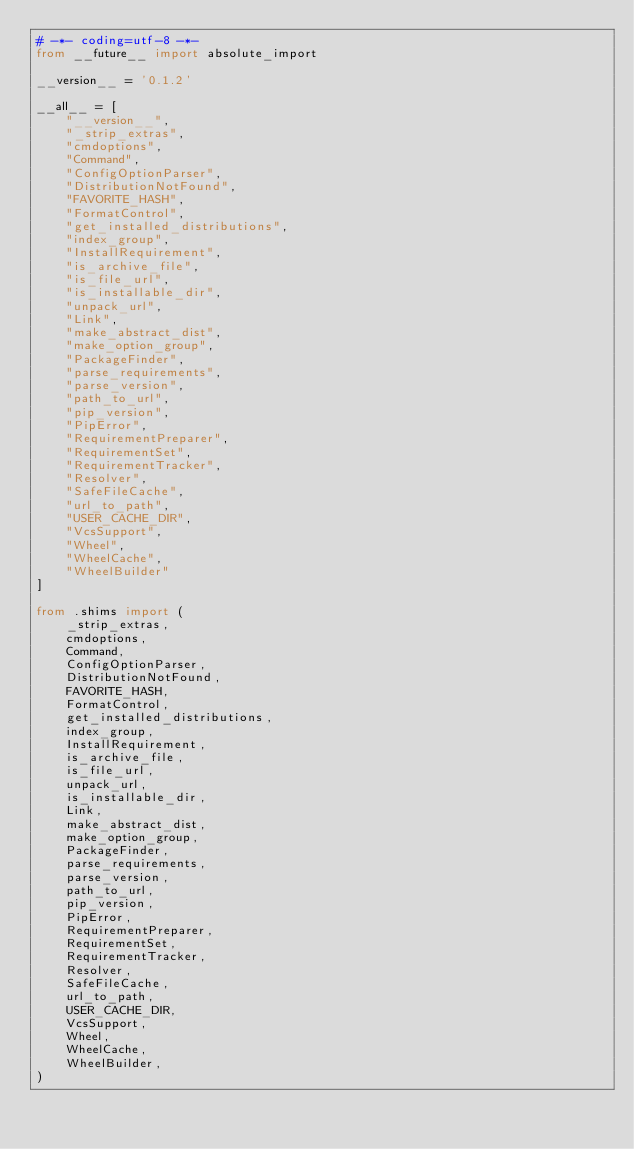Convert code to text. <code><loc_0><loc_0><loc_500><loc_500><_Python_># -*- coding=utf-8 -*-
from __future__ import absolute_import

__version__ = '0.1.2'

__all__ = [
    "__version__",
    "_strip_extras",
    "cmdoptions",
    "Command",
    "ConfigOptionParser",
    "DistributionNotFound",
    "FAVORITE_HASH",
    "FormatControl",
    "get_installed_distributions",
    "index_group",
    "InstallRequirement",
    "is_archive_file",
    "is_file_url",
    "is_installable_dir",
    "unpack_url",
    "Link",
    "make_abstract_dist",
    "make_option_group",
    "PackageFinder",
    "parse_requirements",
    "parse_version",
    "path_to_url",
    "pip_version",
    "PipError",
    "RequirementPreparer",
    "RequirementSet",
    "RequirementTracker",
    "Resolver",
    "SafeFileCache",
    "url_to_path",
    "USER_CACHE_DIR",
    "VcsSupport",
    "Wheel",
    "WheelCache",
    "WheelBuilder"
]

from .shims import (
    _strip_extras,
    cmdoptions,
    Command,
    ConfigOptionParser,
    DistributionNotFound,
    FAVORITE_HASH,
    FormatControl,
    get_installed_distributions,
    index_group,
    InstallRequirement,
    is_archive_file,
    is_file_url,
    unpack_url,
    is_installable_dir,
    Link,
    make_abstract_dist,
    make_option_group,
    PackageFinder,
    parse_requirements,
    parse_version,
    path_to_url,
    pip_version,
    PipError,
    RequirementPreparer,
    RequirementSet,
    RequirementTracker,
    Resolver,
    SafeFileCache,
    url_to_path,
    USER_CACHE_DIR,
    VcsSupport,
    Wheel,
    WheelCache,
    WheelBuilder,
)
</code> 